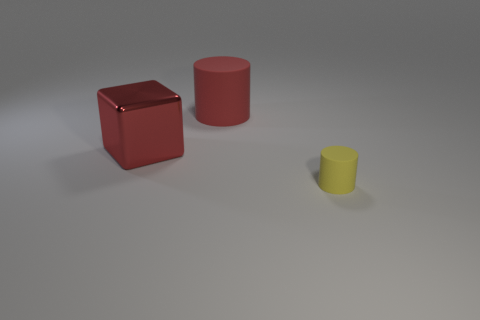Subtract all red cylinders. How many cylinders are left? 1 Add 3 big cylinders. How many objects exist? 6 Subtract all cylinders. How many objects are left? 1 Subtract all blue spheres. How many yellow cylinders are left? 1 Subtract 1 blocks. How many blocks are left? 0 Subtract all blue cylinders. Subtract all yellow blocks. How many cylinders are left? 2 Subtract all cubes. Subtract all green cylinders. How many objects are left? 2 Add 1 yellow things. How many yellow things are left? 2 Add 1 red cylinders. How many red cylinders exist? 2 Subtract 0 green spheres. How many objects are left? 3 